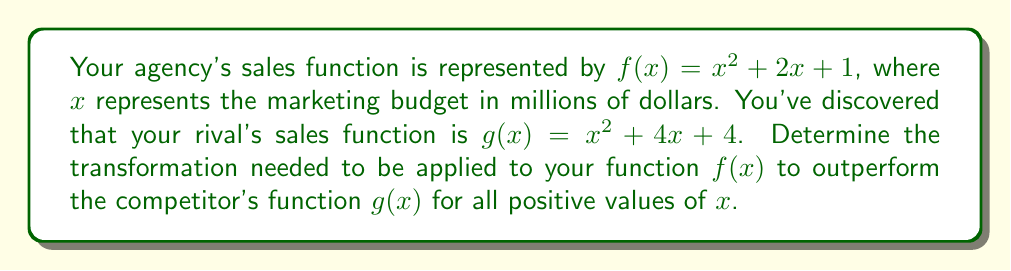Give your solution to this math problem. To outperform the competitor's function, we need to transform $f(x)$ so that it's greater than $g(x)$ for all positive $x$ values.

1) First, let's compare the two functions:
   $f(x) = x^2 + 2x + 1$
   $g(x) = x^2 + 4x + 4$

2) The difference between these functions is:
   $g(x) - f(x) = (x^2 + 4x + 4) - (x^2 + 2x + 1) = 2x + 3$

3) To outperform $g(x)$, we need to add more than this difference to $f(x)$. Let's add $2x + 4$ to $f(x)$:

   $f_{new}(x) = f(x) + (2x + 4) = (x^2 + 2x + 1) + (2x + 4) = x^2 + 4x + 5$

4) Now, let's verify that $f_{new}(x) > g(x)$ for all positive $x$:
   
   $f_{new}(x) - g(x) = (x^2 + 4x + 5) - (x^2 + 4x + 4) = 1$

5) Since this difference is always positive, $f_{new}(x)$ will always be greater than $g(x)$ for all $x$ values.

Therefore, the transformation needed is a vertical shift up by 4 units combined with a stretch in the y-direction by a factor of 2 for the linear term.
Answer: The transformation needed is $f(x) \rightarrow f(x) + 2x + 4$, which can be described as a vertical shift up by 4 units and a stretch in the y-direction by a factor of 2 for the linear term. 